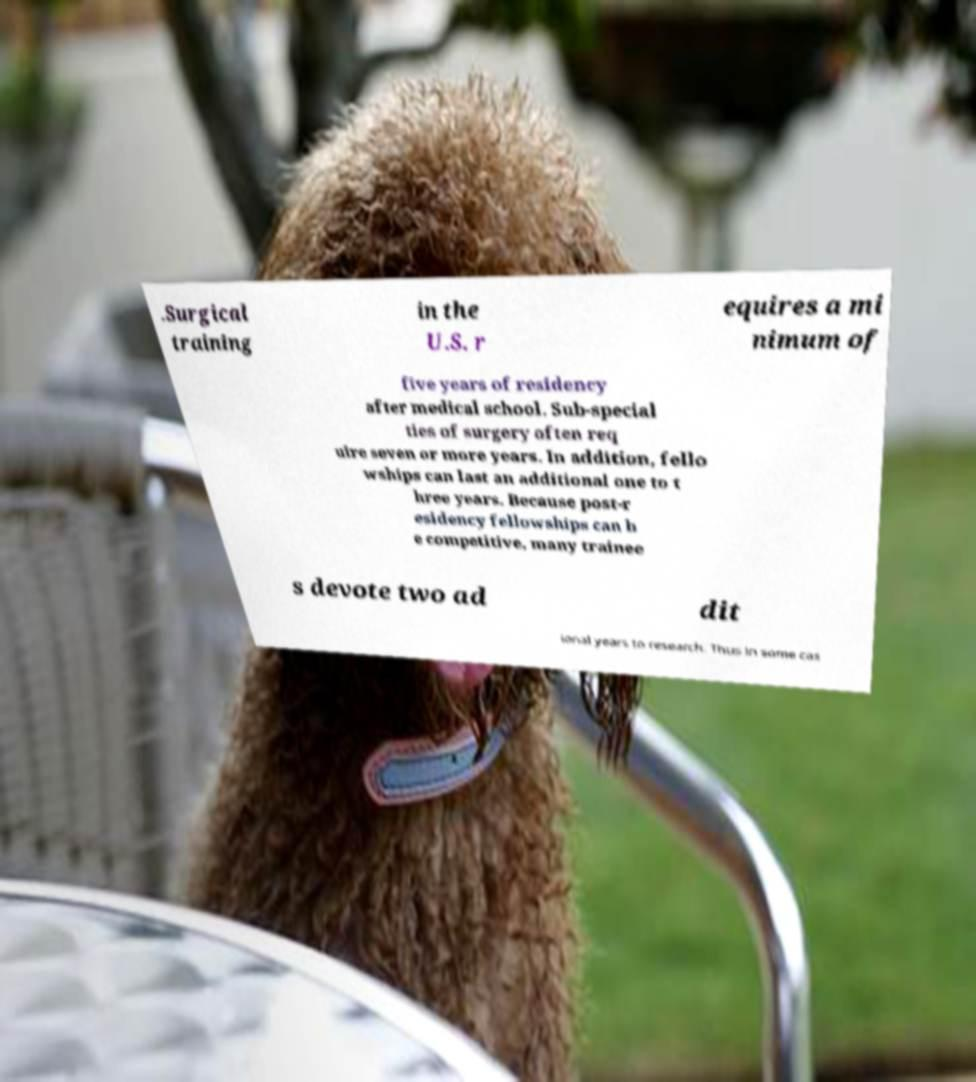Can you accurately transcribe the text from the provided image for me? .Surgical training in the U.S. r equires a mi nimum of five years of residency after medical school. Sub-special ties of surgery often req uire seven or more years. In addition, fello wships can last an additional one to t hree years. Because post-r esidency fellowships can b e competitive, many trainee s devote two ad dit ional years to research. Thus in some cas 